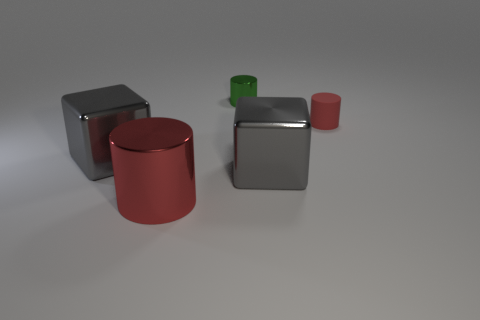Are there any other things that are the same material as the small red cylinder?
Give a very brief answer. No. How many cylinders are tiny metal objects or matte objects?
Your answer should be very brief. 2. What is the material of the other large object that is the same color as the rubber thing?
Offer a terse response. Metal. What number of metallic objects are the same shape as the small red rubber object?
Your answer should be very brief. 2. Is the number of tiny metallic cylinders to the right of the tiny metal thing greater than the number of small objects in front of the large cylinder?
Provide a short and direct response. No. There is a tiny cylinder to the right of the small green thing; is its color the same as the large cylinder?
Provide a short and direct response. Yes. What size is the rubber cylinder?
Offer a very short reply. Small. There is a cylinder that is the same size as the green thing; what is it made of?
Provide a succinct answer. Rubber. What is the color of the cylinder that is in front of the red matte cylinder?
Offer a terse response. Red. What number of tiny matte cylinders are there?
Your answer should be compact. 1. 